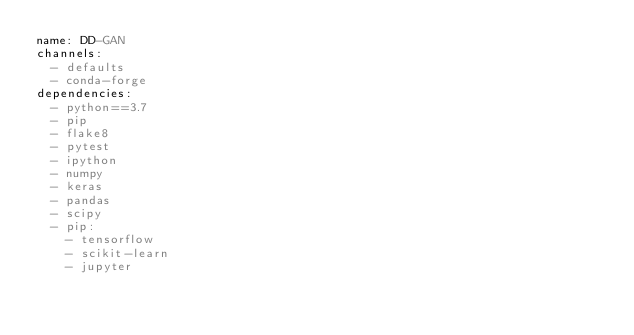Convert code to text. <code><loc_0><loc_0><loc_500><loc_500><_YAML_>name: DD-GAN
channels:
  - defaults
  - conda-forge
dependencies:
  - python==3.7
  - pip
  - flake8
  - pytest
  - ipython
  - numpy
  - keras
  - pandas
  - scipy
  - pip:
    - tensorflow
    - scikit-learn
    - jupyter
</code> 